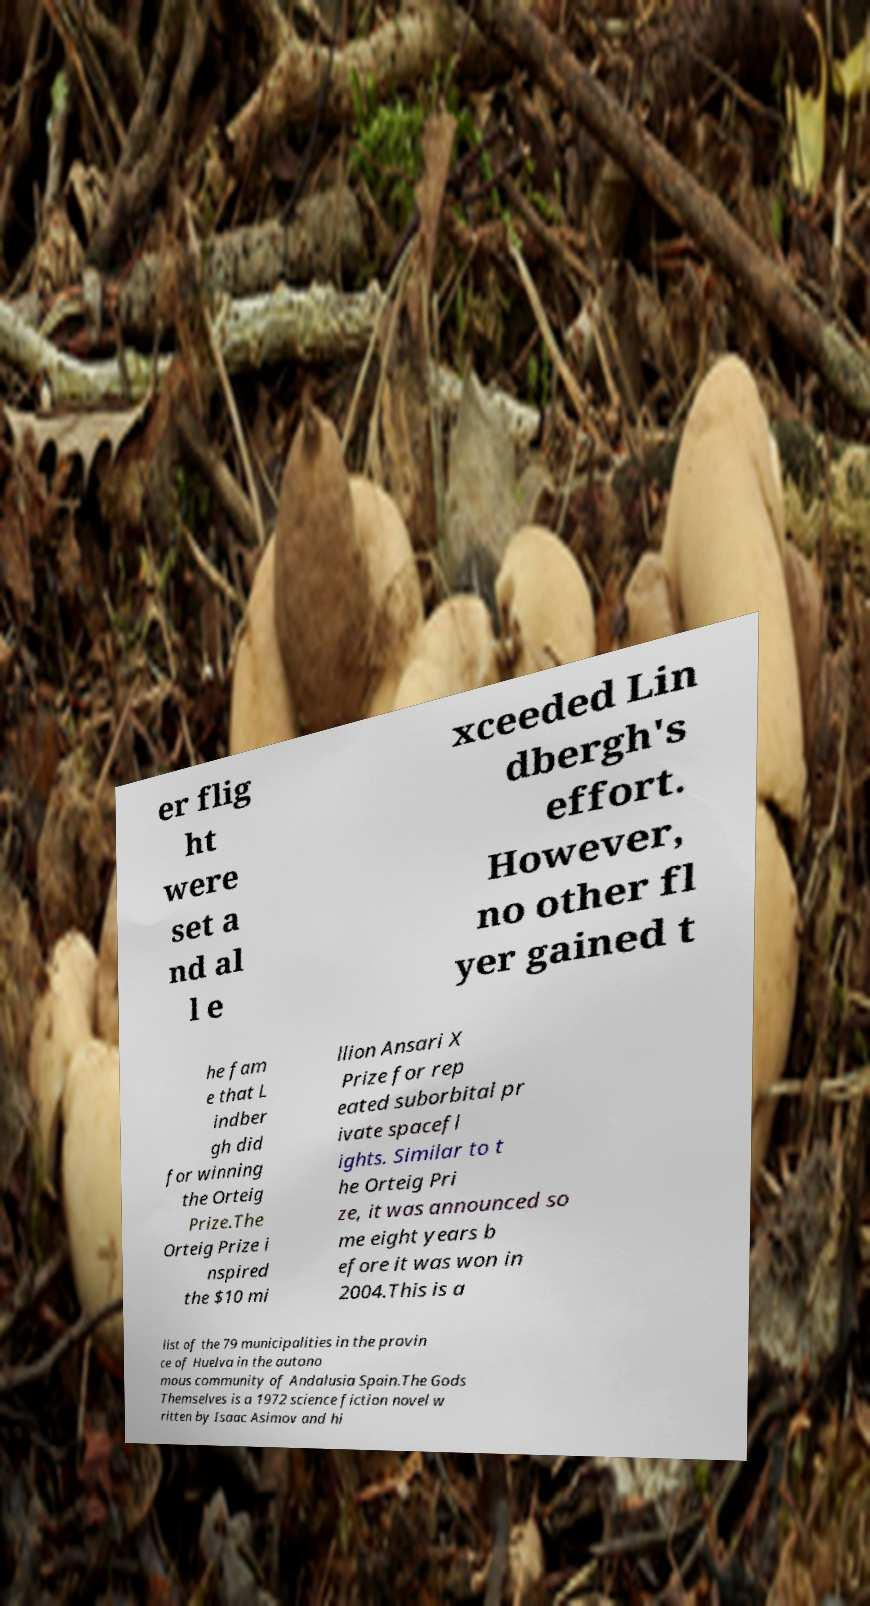What messages or text are displayed in this image? I need them in a readable, typed format. er flig ht were set a nd al l e xceeded Lin dbergh's effort. However, no other fl yer gained t he fam e that L indber gh did for winning the Orteig Prize.The Orteig Prize i nspired the $10 mi llion Ansari X Prize for rep eated suborbital pr ivate spacefl ights. Similar to t he Orteig Pri ze, it was announced so me eight years b efore it was won in 2004.This is a list of the 79 municipalities in the provin ce of Huelva in the autono mous community of Andalusia Spain.The Gods Themselves is a 1972 science fiction novel w ritten by Isaac Asimov and hi 